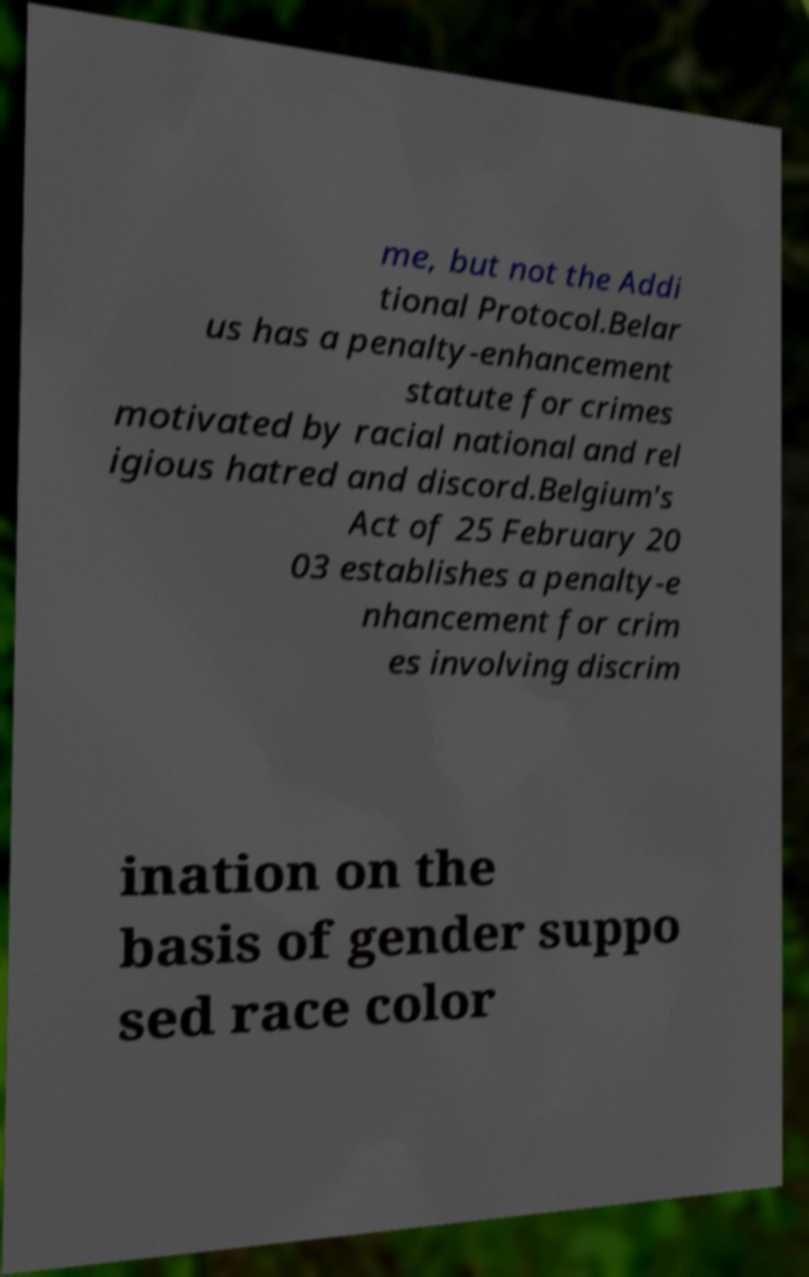There's text embedded in this image that I need extracted. Can you transcribe it verbatim? me, but not the Addi tional Protocol.Belar us has a penalty-enhancement statute for crimes motivated by racial national and rel igious hatred and discord.Belgium's Act of 25 February 20 03 establishes a penalty-e nhancement for crim es involving discrim ination on the basis of gender suppo sed race color 